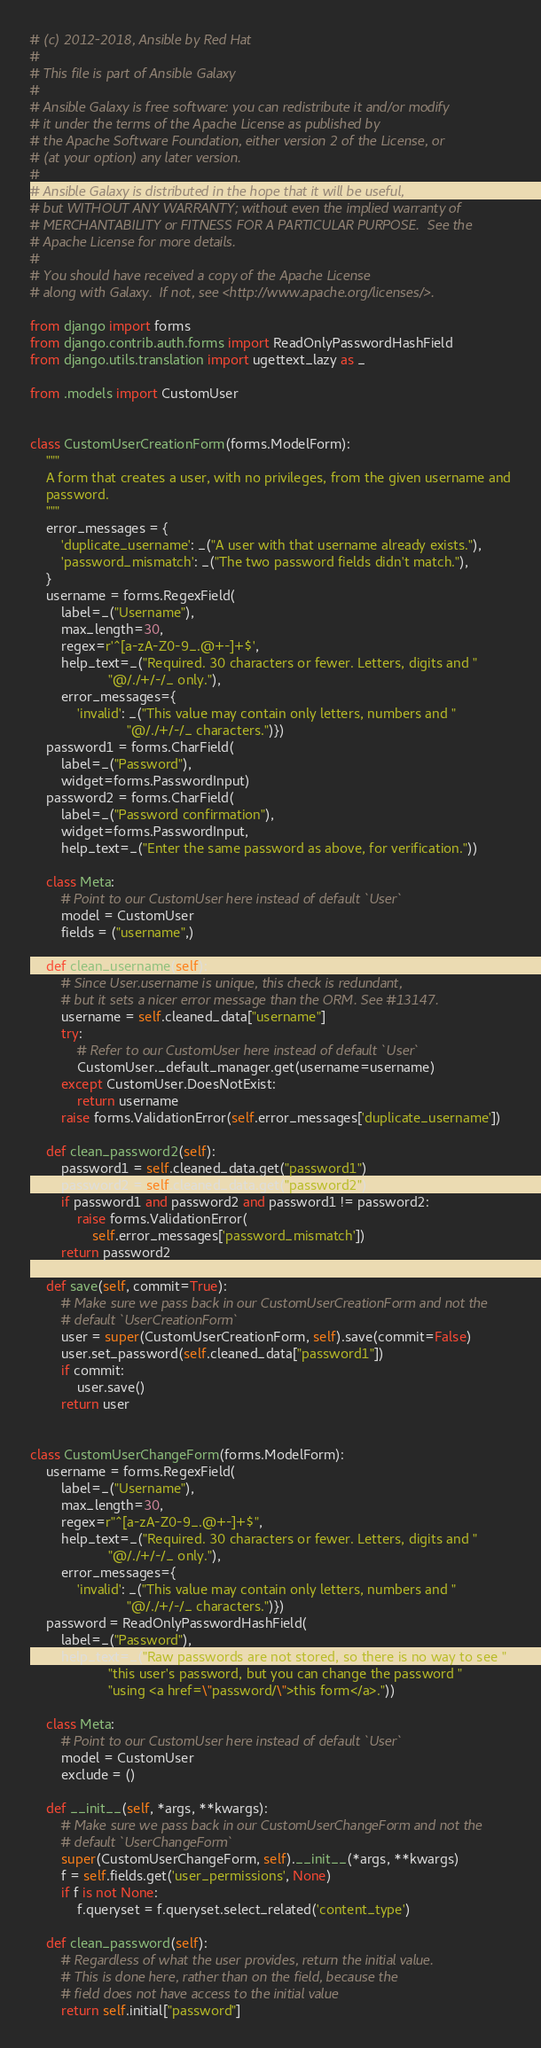Convert code to text. <code><loc_0><loc_0><loc_500><loc_500><_Python_># (c) 2012-2018, Ansible by Red Hat
#
# This file is part of Ansible Galaxy
#
# Ansible Galaxy is free software: you can redistribute it and/or modify
# it under the terms of the Apache License as published by
# the Apache Software Foundation, either version 2 of the License, or
# (at your option) any later version.
#
# Ansible Galaxy is distributed in the hope that it will be useful,
# but WITHOUT ANY WARRANTY; without even the implied warranty of
# MERCHANTABILITY or FITNESS FOR A PARTICULAR PURPOSE.  See the
# Apache License for more details.
#
# You should have received a copy of the Apache License
# along with Galaxy.  If not, see <http://www.apache.org/licenses/>.

from django import forms
from django.contrib.auth.forms import ReadOnlyPasswordHashField
from django.utils.translation import ugettext_lazy as _

from .models import CustomUser


class CustomUserCreationForm(forms.ModelForm):
    """
    A form that creates a user, with no privileges, from the given username and
    password.
    """
    error_messages = {
        'duplicate_username': _("A user with that username already exists."),
        'password_mismatch': _("The two password fields didn't match."),
    }
    username = forms.RegexField(
        label=_("Username"),
        max_length=30,
        regex=r'^[a-zA-Z0-9_.@+-]+$',
        help_text=_("Required. 30 characters or fewer. Letters, digits and "
                    "@/./+/-/_ only."),
        error_messages={
            'invalid': _("This value may contain only letters, numbers and "
                         "@/./+/-/_ characters.")})
    password1 = forms.CharField(
        label=_("Password"),
        widget=forms.PasswordInput)
    password2 = forms.CharField(
        label=_("Password confirmation"),
        widget=forms.PasswordInput,
        help_text=_("Enter the same password as above, for verification."))

    class Meta:
        # Point to our CustomUser here instead of default `User`
        model = CustomUser
        fields = ("username",)

    def clean_username(self):
        # Since User.username is unique, this check is redundant,
        # but it sets a nicer error message than the ORM. See #13147.
        username = self.cleaned_data["username"]
        try:
            # Refer to our CustomUser here instead of default `User`
            CustomUser._default_manager.get(username=username)
        except CustomUser.DoesNotExist:
            return username
        raise forms.ValidationError(self.error_messages['duplicate_username'])

    def clean_password2(self):
        password1 = self.cleaned_data.get("password1")
        password2 = self.cleaned_data.get("password2")
        if password1 and password2 and password1 != password2:
            raise forms.ValidationError(
                self.error_messages['password_mismatch'])
        return password2

    def save(self, commit=True):
        # Make sure we pass back in our CustomUserCreationForm and not the
        # default `UserCreationForm`
        user = super(CustomUserCreationForm, self).save(commit=False)
        user.set_password(self.cleaned_data["password1"])
        if commit:
            user.save()
        return user


class CustomUserChangeForm(forms.ModelForm):
    username = forms.RegexField(
        label=_("Username"),
        max_length=30,
        regex=r"^[a-zA-Z0-9_.@+-]+$",
        help_text=_("Required. 30 characters or fewer. Letters, digits and "
                    "@/./+/-/_ only."),
        error_messages={
            'invalid': _("This value may contain only letters, numbers and "
                         "@/./+/-/_ characters.")})
    password = ReadOnlyPasswordHashField(
        label=_("Password"),
        help_text=_("Raw passwords are not stored, so there is no way to see "
                    "this user's password, but you can change the password "
                    "using <a href=\"password/\">this form</a>."))

    class Meta:
        # Point to our CustomUser here instead of default `User`
        model = CustomUser
        exclude = ()

    def __init__(self, *args, **kwargs):
        # Make sure we pass back in our CustomUserChangeForm and not the
        # default `UserChangeForm`
        super(CustomUserChangeForm, self).__init__(*args, **kwargs)
        f = self.fields.get('user_permissions', None)
        if f is not None:
            f.queryset = f.queryset.select_related('content_type')

    def clean_password(self):
        # Regardless of what the user provides, return the initial value.
        # This is done here, rather than on the field, because the
        # field does not have access to the initial value
        return self.initial["password"]
</code> 